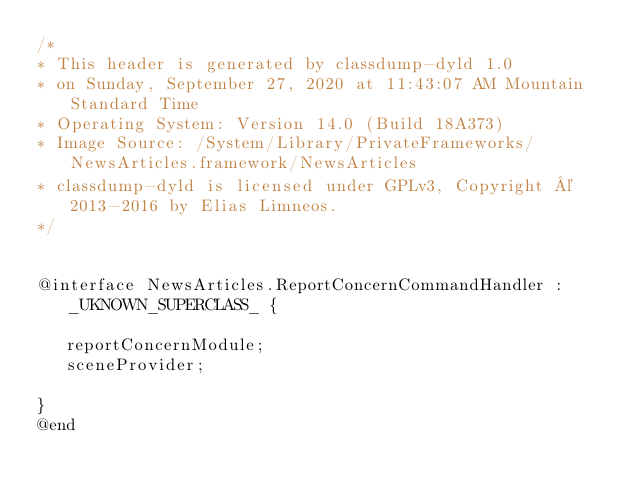<code> <loc_0><loc_0><loc_500><loc_500><_C_>/*
* This header is generated by classdump-dyld 1.0
* on Sunday, September 27, 2020 at 11:43:07 AM Mountain Standard Time
* Operating System: Version 14.0 (Build 18A373)
* Image Source: /System/Library/PrivateFrameworks/NewsArticles.framework/NewsArticles
* classdump-dyld is licensed under GPLv3, Copyright © 2013-2016 by Elias Limneos.
*/


@interface NewsArticles.ReportConcernCommandHandler : _UKNOWN_SUPERCLASS_ {

	 reportConcernModule;
	 sceneProvider;

}
@end

</code> 